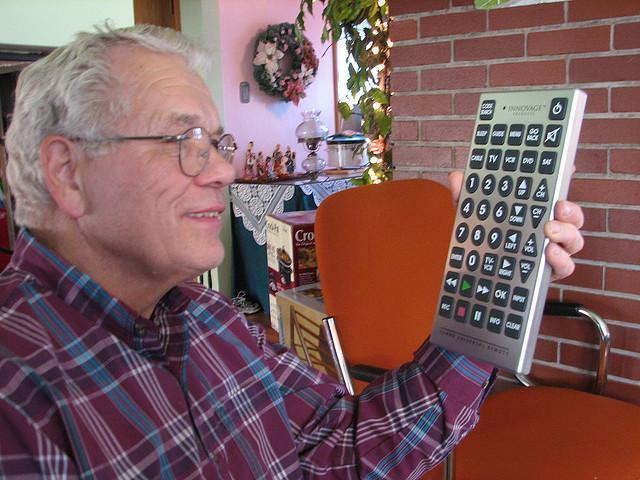How many levels does the bus have?
Give a very brief answer. 0. 